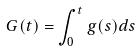<formula> <loc_0><loc_0><loc_500><loc_500>G ( t ) = \int _ { 0 } ^ { t } g ( s ) d s</formula> 